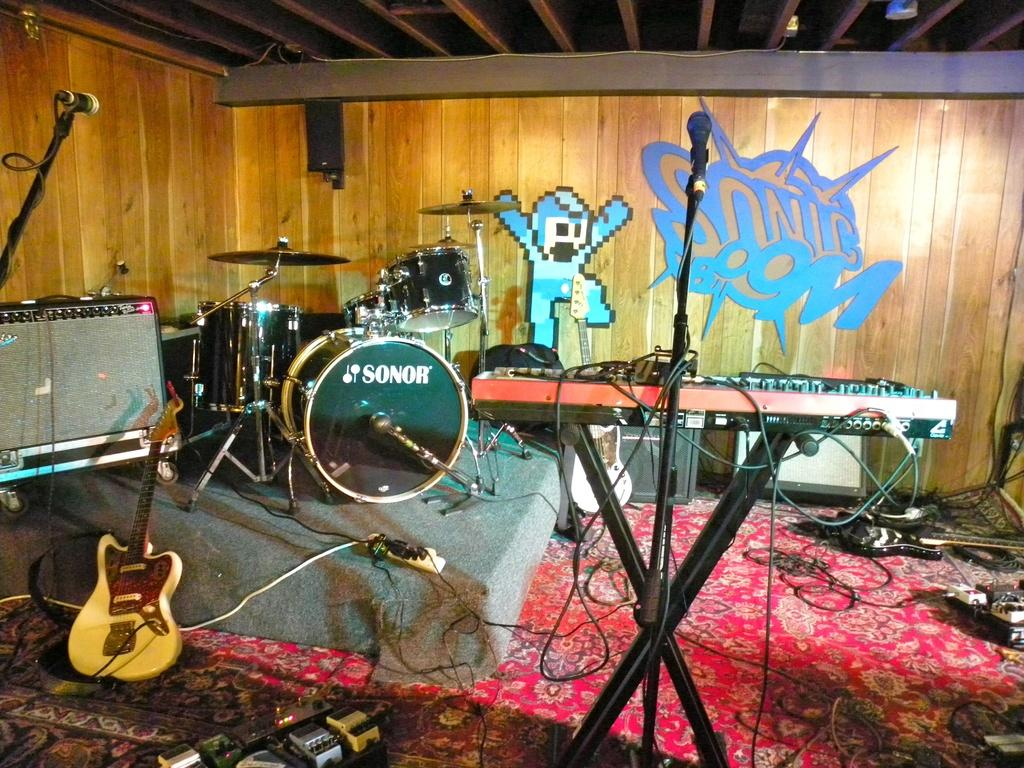What type of space is depicted in the image? The image is of a room. What can be found in the room? There are different types of musical instruments and speakers in the room. Are there any decorations on the walls? Yes, there are posters on the walls. Can you see a giraffe in the room? No, there is no giraffe present in the image. What type of string is used to hold the musical instruments in the room? The provided facts do not mention any strings being used to hold the musical instruments in the room. 